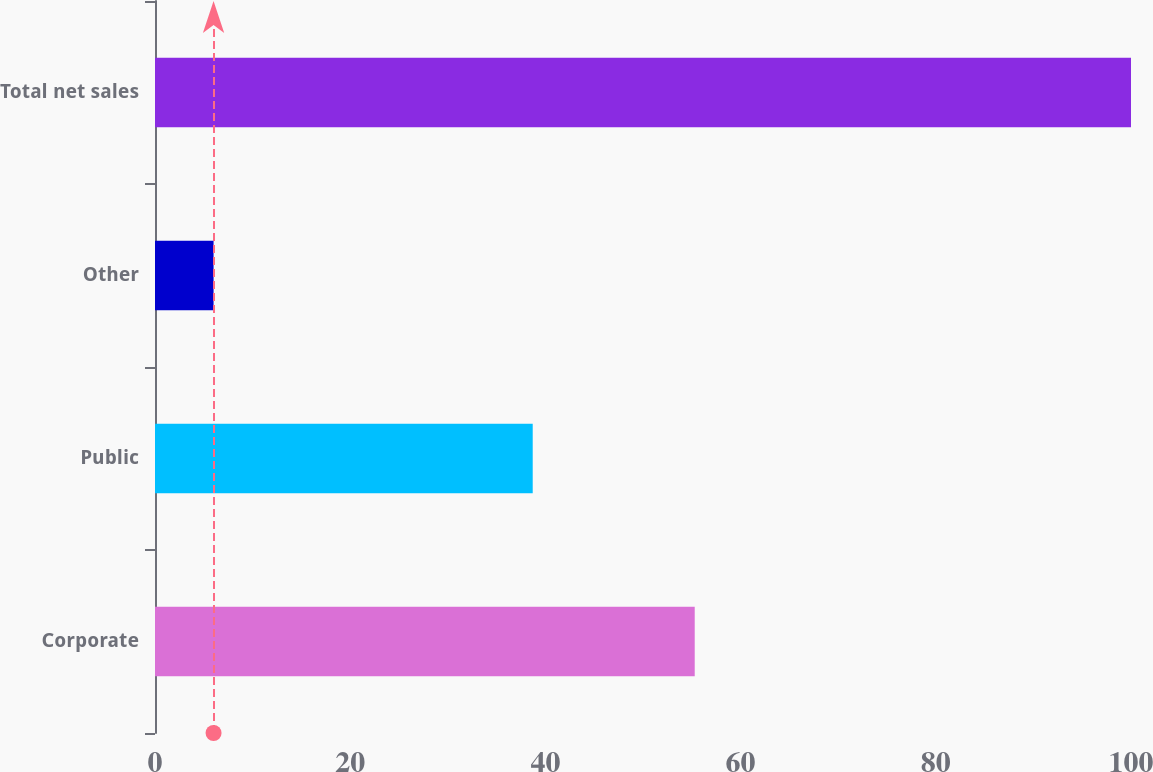<chart> <loc_0><loc_0><loc_500><loc_500><bar_chart><fcel>Corporate<fcel>Public<fcel>Other<fcel>Total net sales<nl><fcel>55.3<fcel>38.7<fcel>6<fcel>100<nl></chart> 